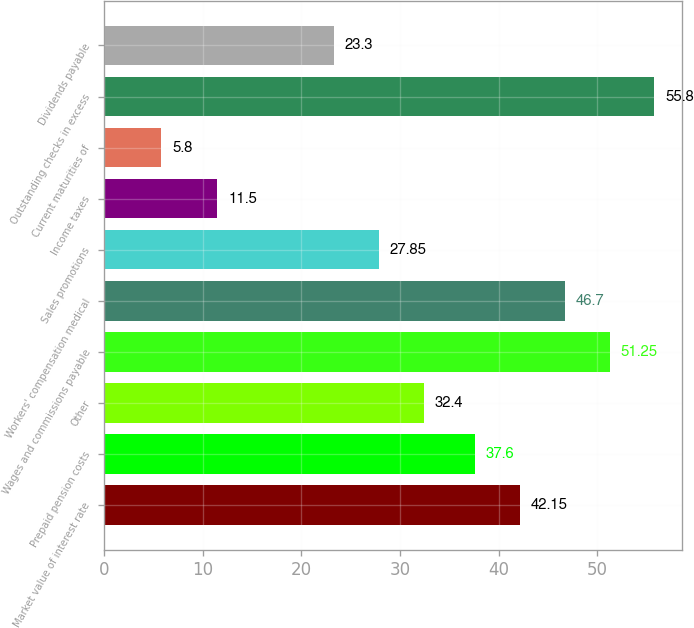Convert chart to OTSL. <chart><loc_0><loc_0><loc_500><loc_500><bar_chart><fcel>Market value of interest rate<fcel>Prepaid pension costs<fcel>Other<fcel>Wages and commissions payable<fcel>Workers' compensation medical<fcel>Sales promotions<fcel>Income taxes<fcel>Current maturities of<fcel>Outstanding checks in excess<fcel>Dividends payable<nl><fcel>42.15<fcel>37.6<fcel>32.4<fcel>51.25<fcel>46.7<fcel>27.85<fcel>11.5<fcel>5.8<fcel>55.8<fcel>23.3<nl></chart> 